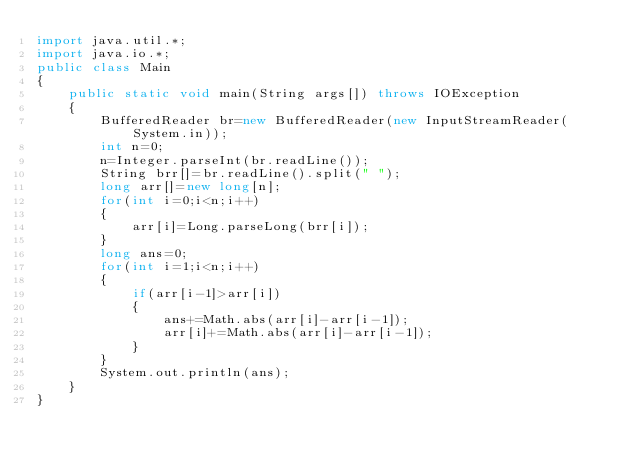Convert code to text. <code><loc_0><loc_0><loc_500><loc_500><_Java_>import java.util.*;
import java.io.*;
public class Main
{
	public static void main(String args[]) throws IOException
	{
		BufferedReader br=new BufferedReader(new InputStreamReader(System.in));
		int n=0;
		n=Integer.parseInt(br.readLine());
		String brr[]=br.readLine().split(" ");
		long arr[]=new long[n];
		for(int i=0;i<n;i++)
		{
			arr[i]=Long.parseLong(brr[i]);
		}
		long ans=0;
		for(int i=1;i<n;i++)
		{
			if(arr[i-1]>arr[i])
			{
				ans+=Math.abs(arr[i]-arr[i-1]);
				arr[i]+=Math.abs(arr[i]-arr[i-1]);
			}
		}
		System.out.println(ans);
	}
}		</code> 